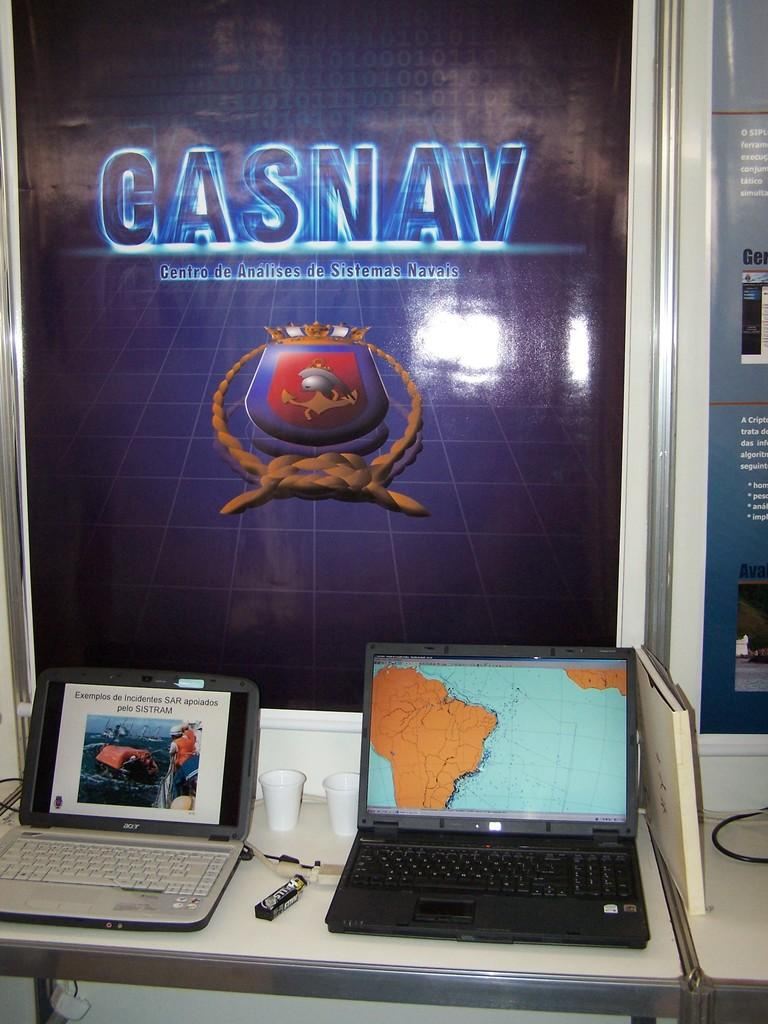<image>
Relay a brief, clear account of the picture shown. Poster behind two laptops that says Casnav on it. 